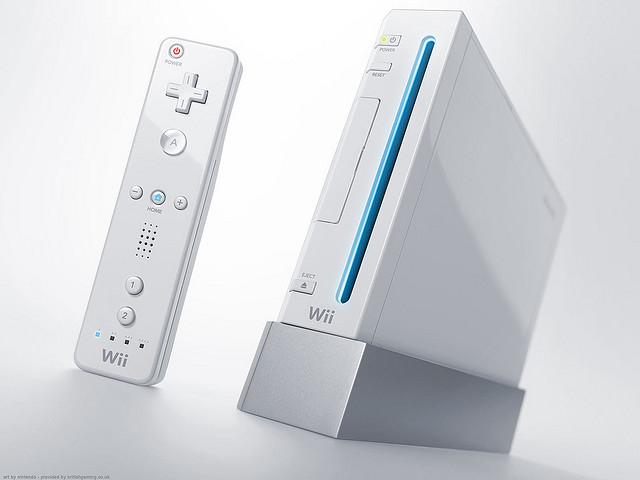Is this an advertisement?
Concise answer only. Yes. Is this a sleek design?
Give a very brief answer. Yes. What type of game console is this?
Concise answer only. Wii. 